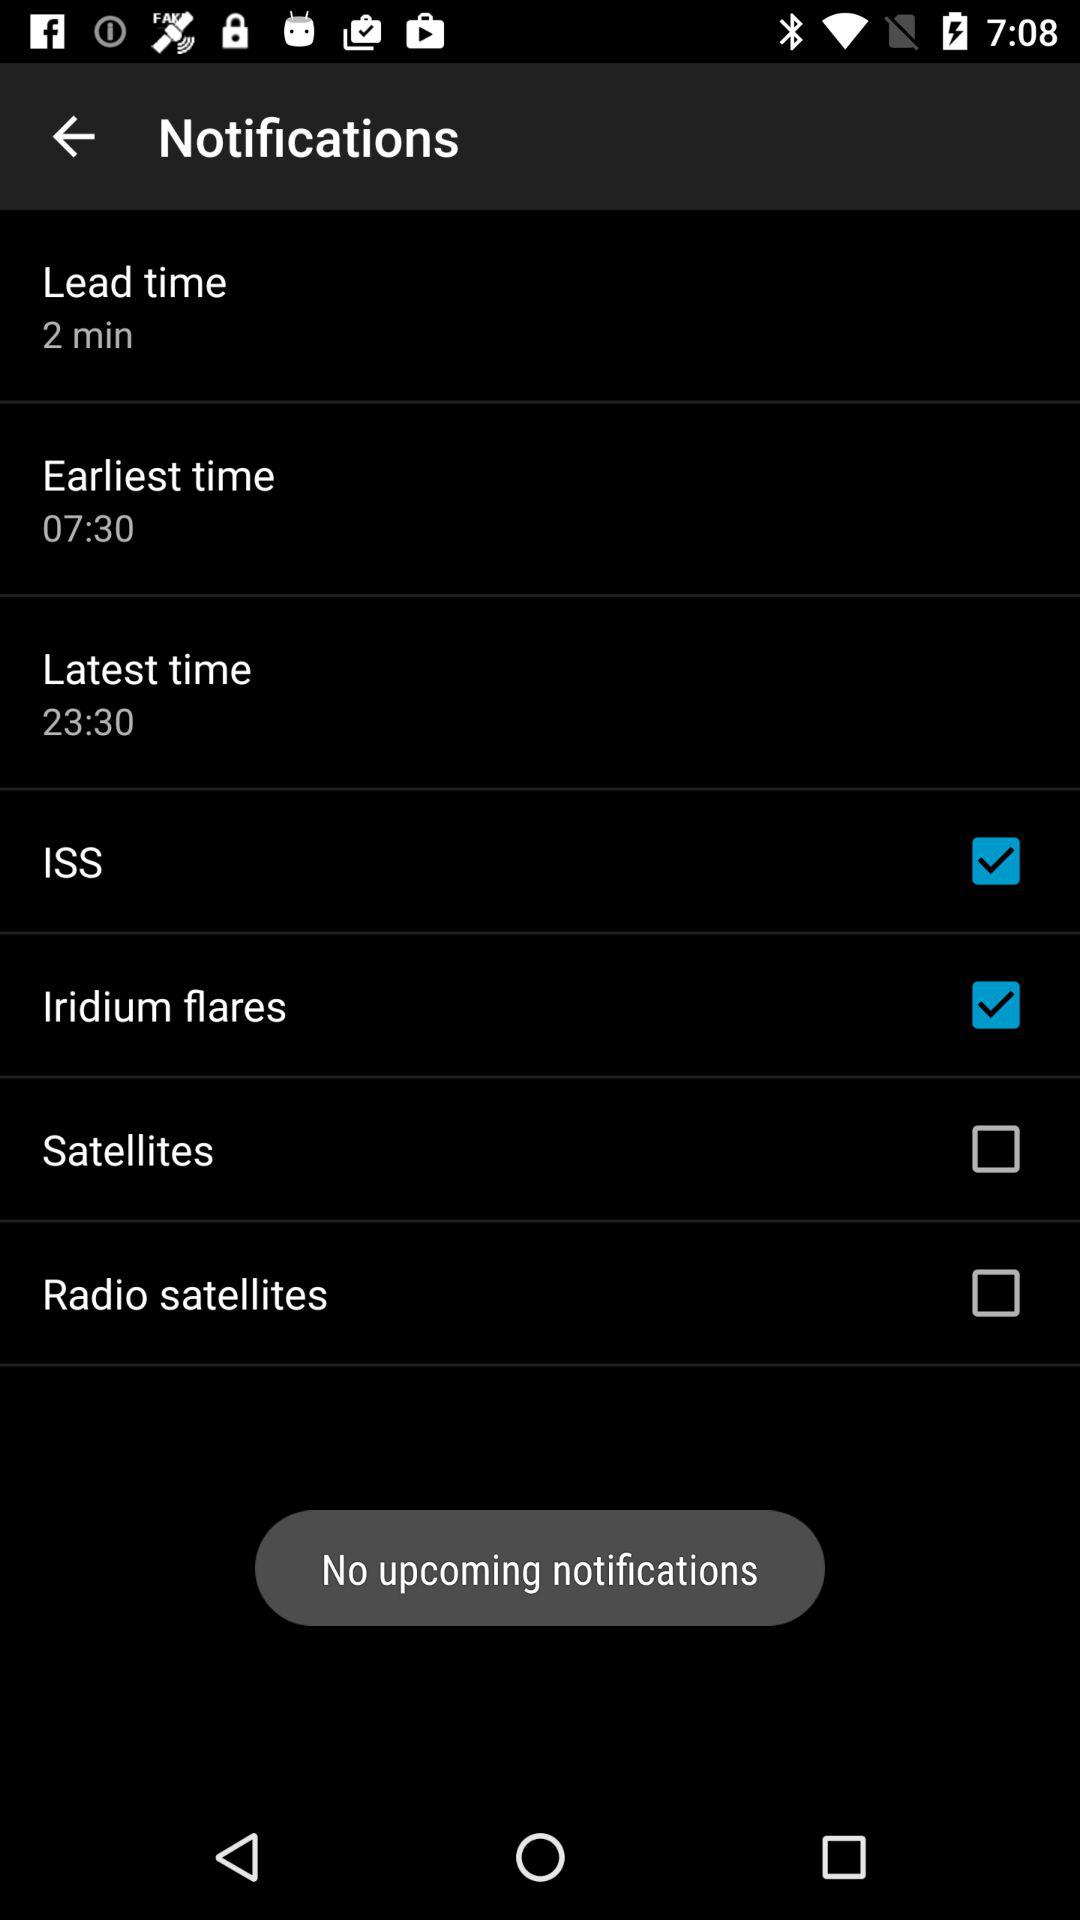Are there any upcoming notifications? There are no upcoming notifications. 